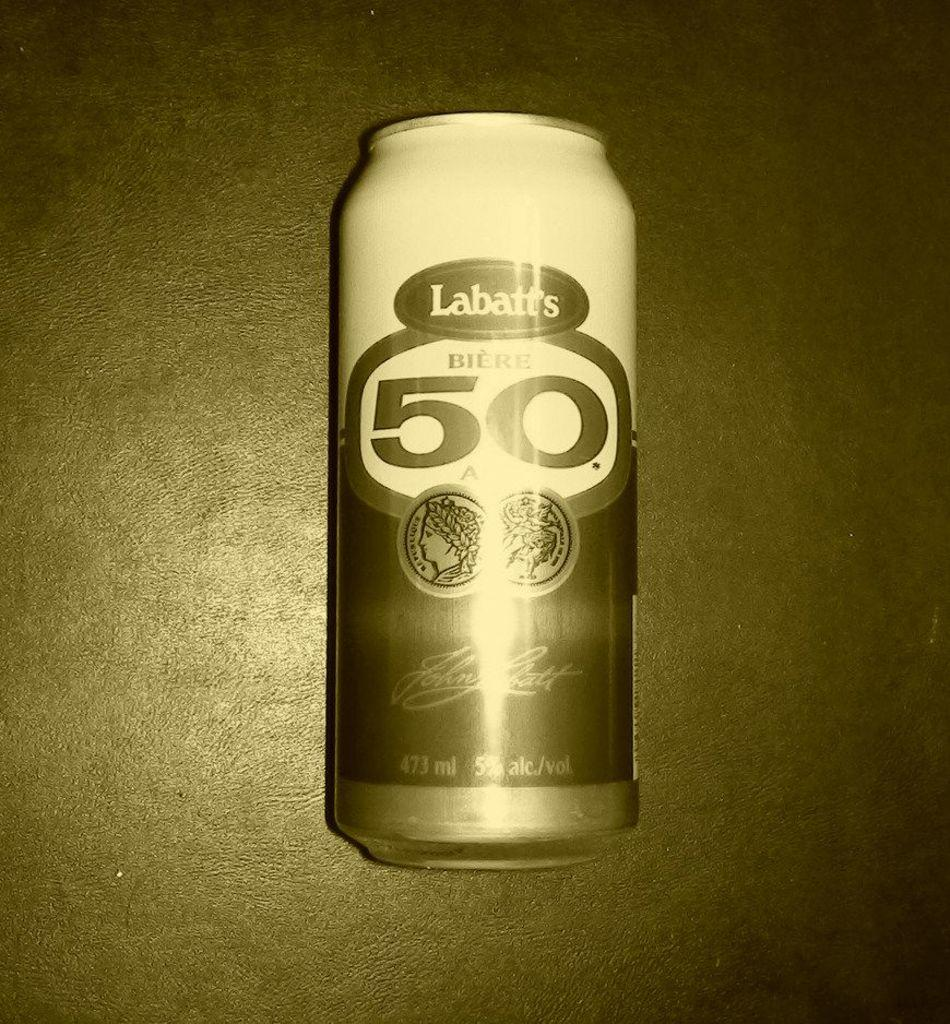Provide a one-sentence caption for the provided image. a can of Labatts 50 beer with a tin filter on it. 